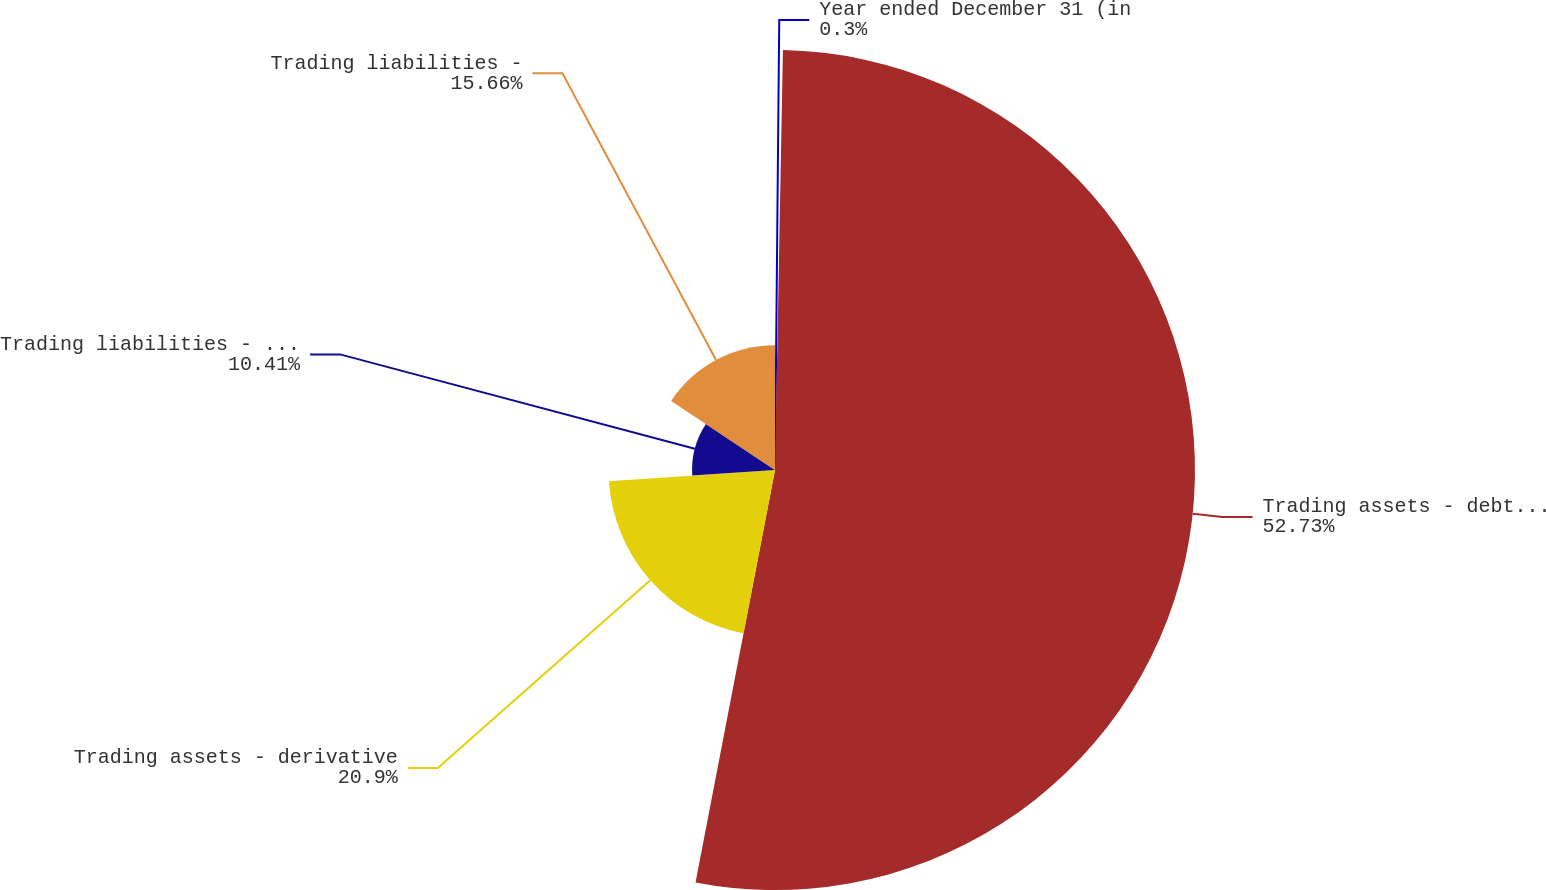Convert chart to OTSL. <chart><loc_0><loc_0><loc_500><loc_500><pie_chart><fcel>Year ended December 31 (in<fcel>Trading assets - debt and<fcel>Trading assets - derivative<fcel>Trading liabilities - debt and<fcel>Trading liabilities -<nl><fcel>0.3%<fcel>52.73%<fcel>20.9%<fcel>10.41%<fcel>15.66%<nl></chart> 